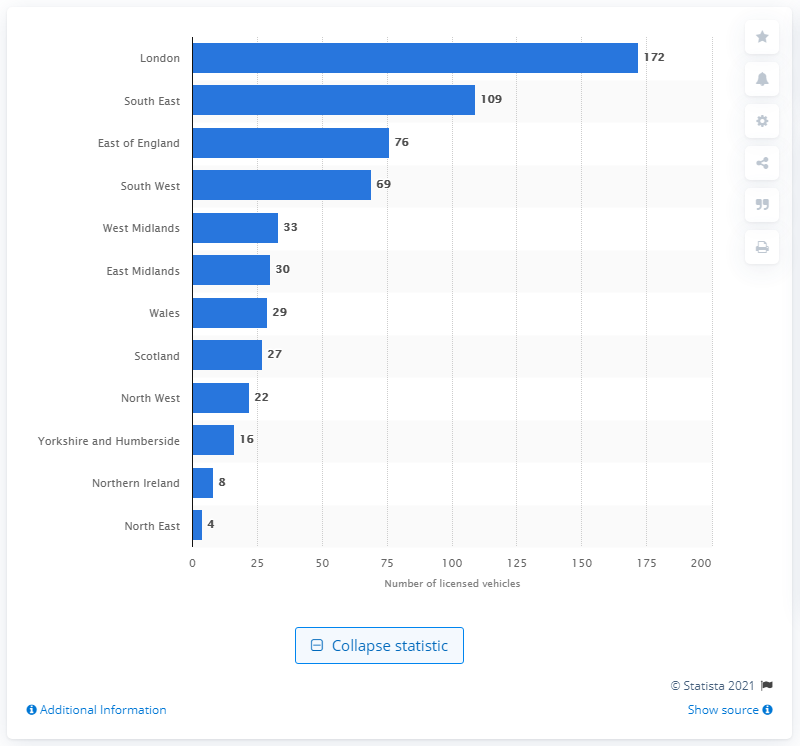List a handful of essential elements in this visual. In the third quarter of 2018, a total of 16 quadricycles were licensed in the region of Yorkshire and Humberside. 